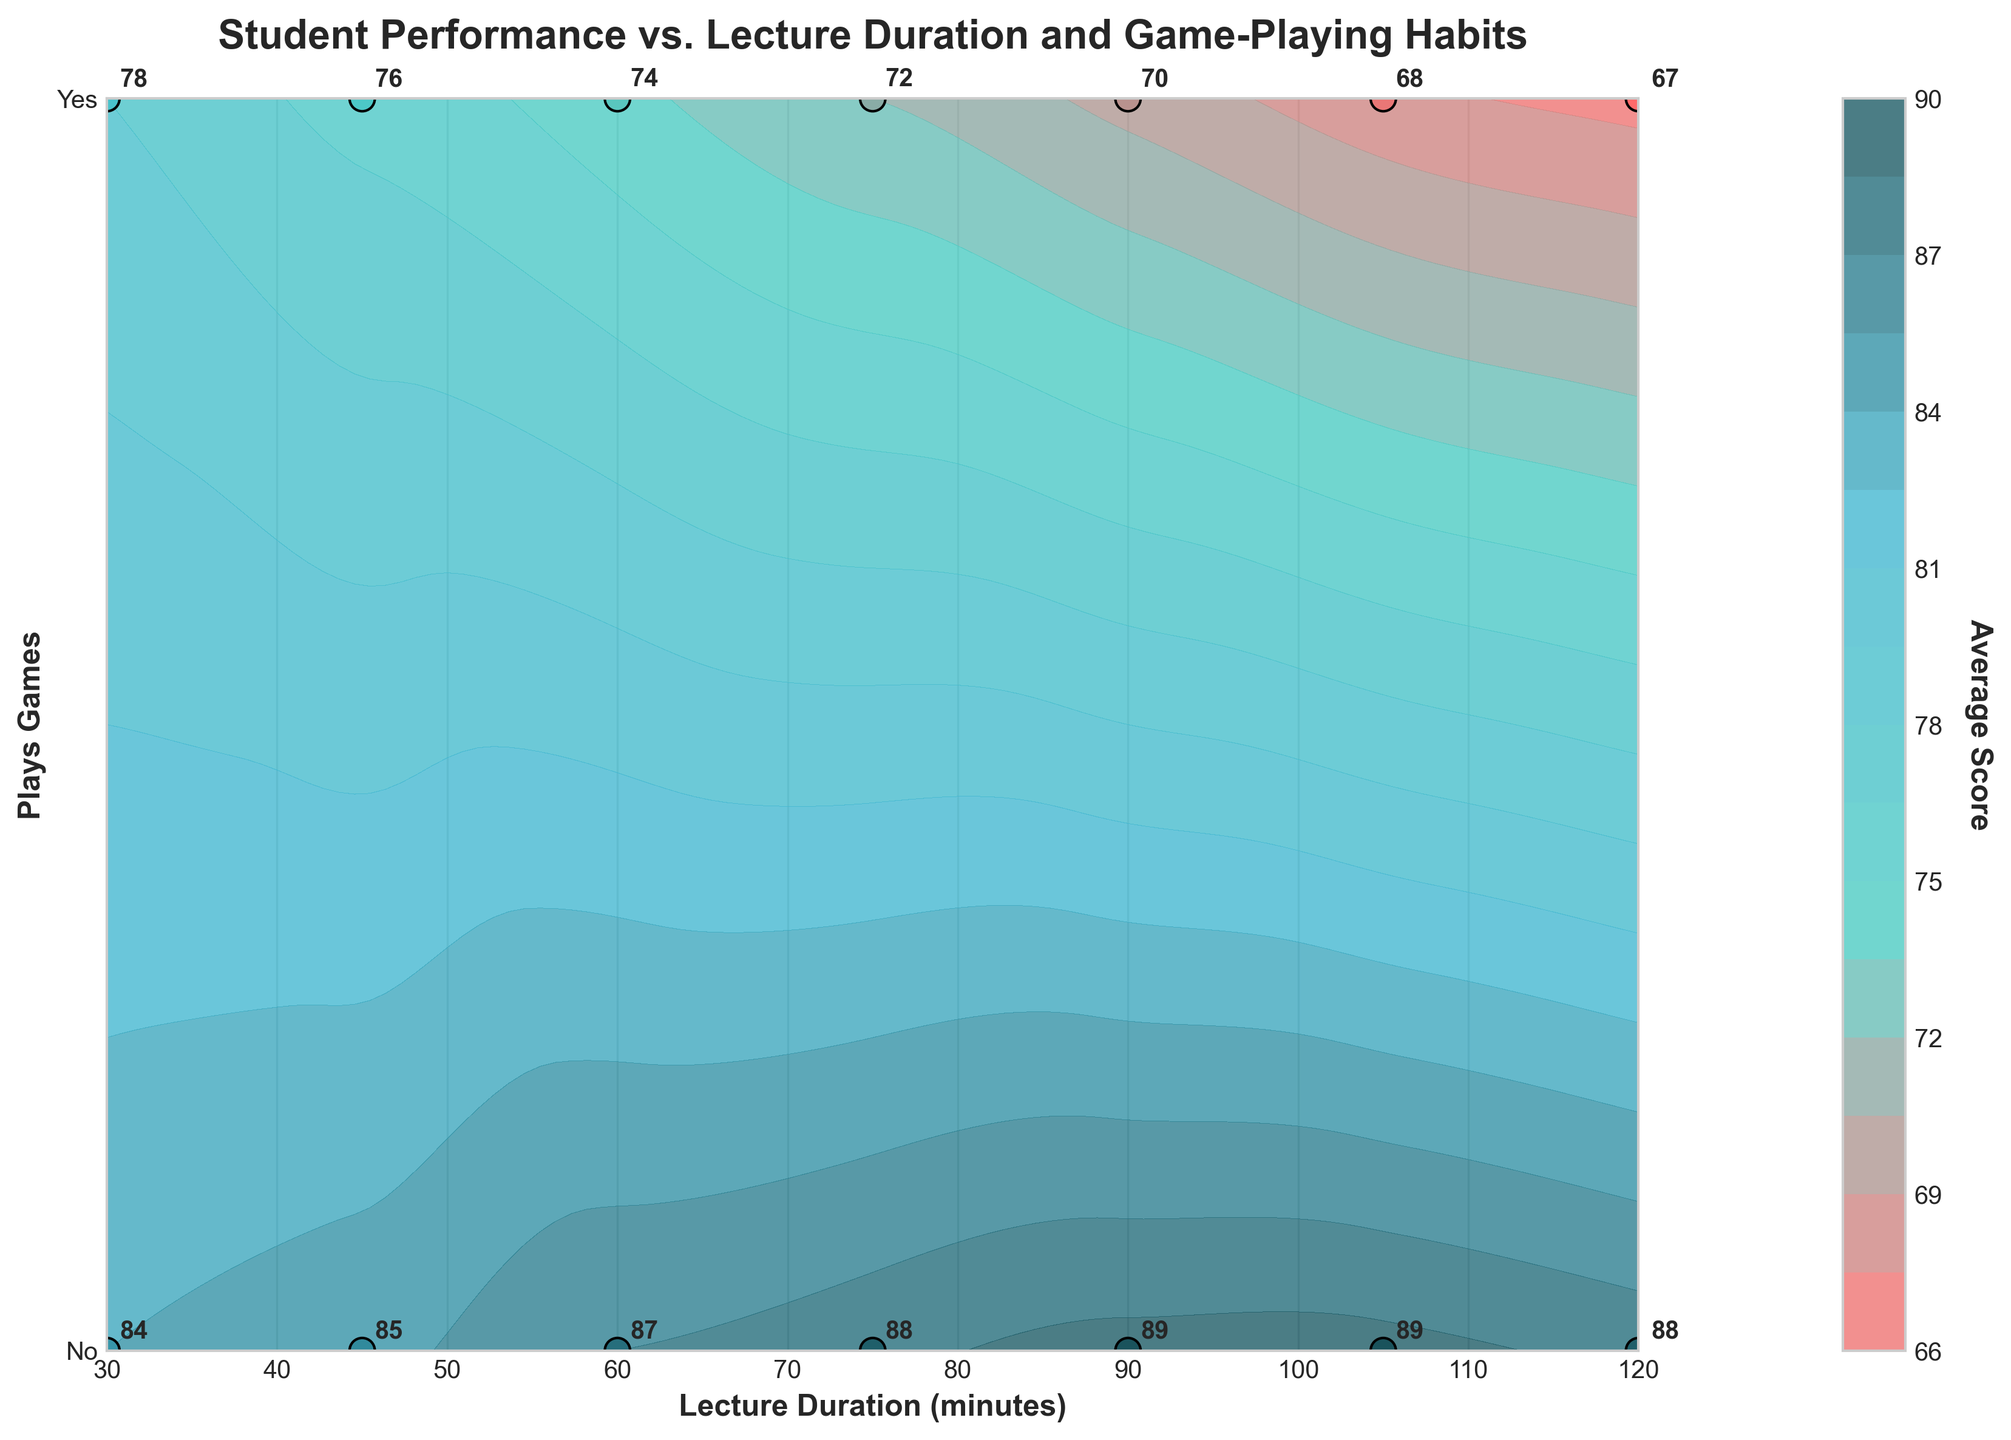What is the title of the plot? The title of the plot is located at the top and is bolded for emphasis. It states the main focus of the figure, which is the relationship between student performance, lecture duration, and game-playing habits.
Answer: Student Performance vs. Lecture Duration and Game-Playing Habits What do the labels on the x-axis and y-axis represent? The x-axis label is located at the bottom and indicates the varying durations of the lectures in minutes. The y-axis label is on the left, specifying whether students play games or not during lectures.
Answer: Lecture Duration (minutes) and Plays Games How many unique lecture durations are displayed? By counting the distinct data points along the x-axis, we observe the different lecture durations plotted on the grid. These are spaced apart evenly from 30 to 120 minutes.
Answer: 7 What is the color associated with the highest scores and the lowest scores in the plot? By examining the color gradient in the contour plot's legend, the highest scores are represented by darker shades (appearing closer to dark teal), while the lowest scores are represented by lighter shades (closer to light pink).
Answer: Dark teal for highest, light pink for lowest Which category of students tends to have higher average scores for most lecture durations, those who play games or those who do not? By observing the contour colors and placement of average scores, we notice that the contour areas indicating higher scores (darker shades) are consistently towards the "No" (do not play games) side of the y-axis, across multiple lecture durations.
Answer: Those who do not play games What is the difference in the average score between students who play games and those who don't for a 60-minute lecture? The plot shows the specific average scores for both groups at 60 minutes. For "Yes" it's 74, and for "No" it's 87. Subtracting these gives the score difference.
Answer: 13 How does the average score trend change for game-playing students as lecture duration increases from 30 to 120 minutes? By tracking the color shades and annotated scores along the y-axis for "Yes", we see a trend where the scores gradually decrease from 78 at 30 minutes to 67 at 120 minutes.
Answer: Decreasing trend Which data point has the highest average score, and what are its associated lecture duration and game-playing habit? Looking at the highest contour area and annotations, the "No" category consistently has higher values. The highest shown is 89, which corresponds to a lecture duration of 90 and 105 minutes.
Answer: 89 at 90 and 105 minutes (No games) What does a y-tick value of 1 represent? The y-ticks are labeled as 0 and 1, with corresponding textual labels "No" and "Yes". Here, 1 aligns with "Yes", indicating students who play games.
Answer: Students who play games Is there a significant difference in average scores between students who play games and those who don't at any lecture duration? If yes, specify those durations. By comparing the scores at each lecture duration, large differences are noticeable where "No" scores are consistently higher. Significant differences can be observed, e.g., 13 points difference at 60 minutes and 19 points at 120 minutes.
Answer: Yes, e.g., at 60 and 120 minutes 